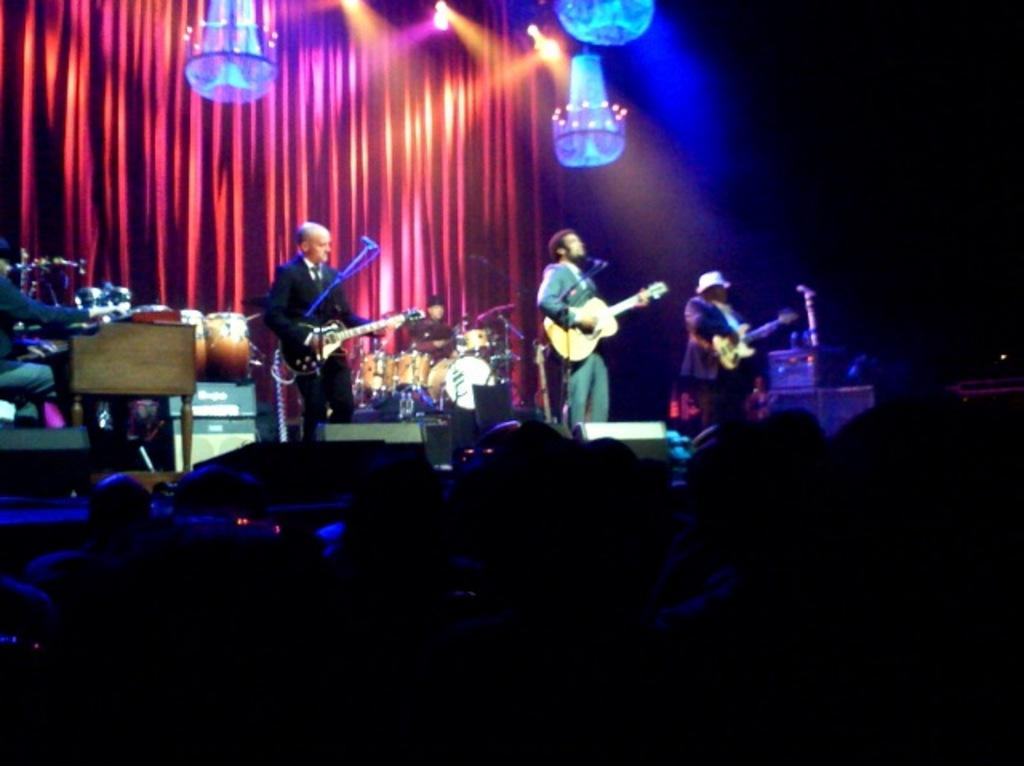How many people are in the group depicted in the image? There is a group of people in the image. What are some of the people in the group doing? Some people in the group are standing, and at least one person is playing a guitar. What can be seen in the background of the image? There is a chandelier and a curtain in the background of the image. Are there any other musicians in the background? Yes, there is another person in the background playing drums. What language is the cable using to communicate with the foot in the image? There is no cable or foot present in the image, so this question cannot be answered. 